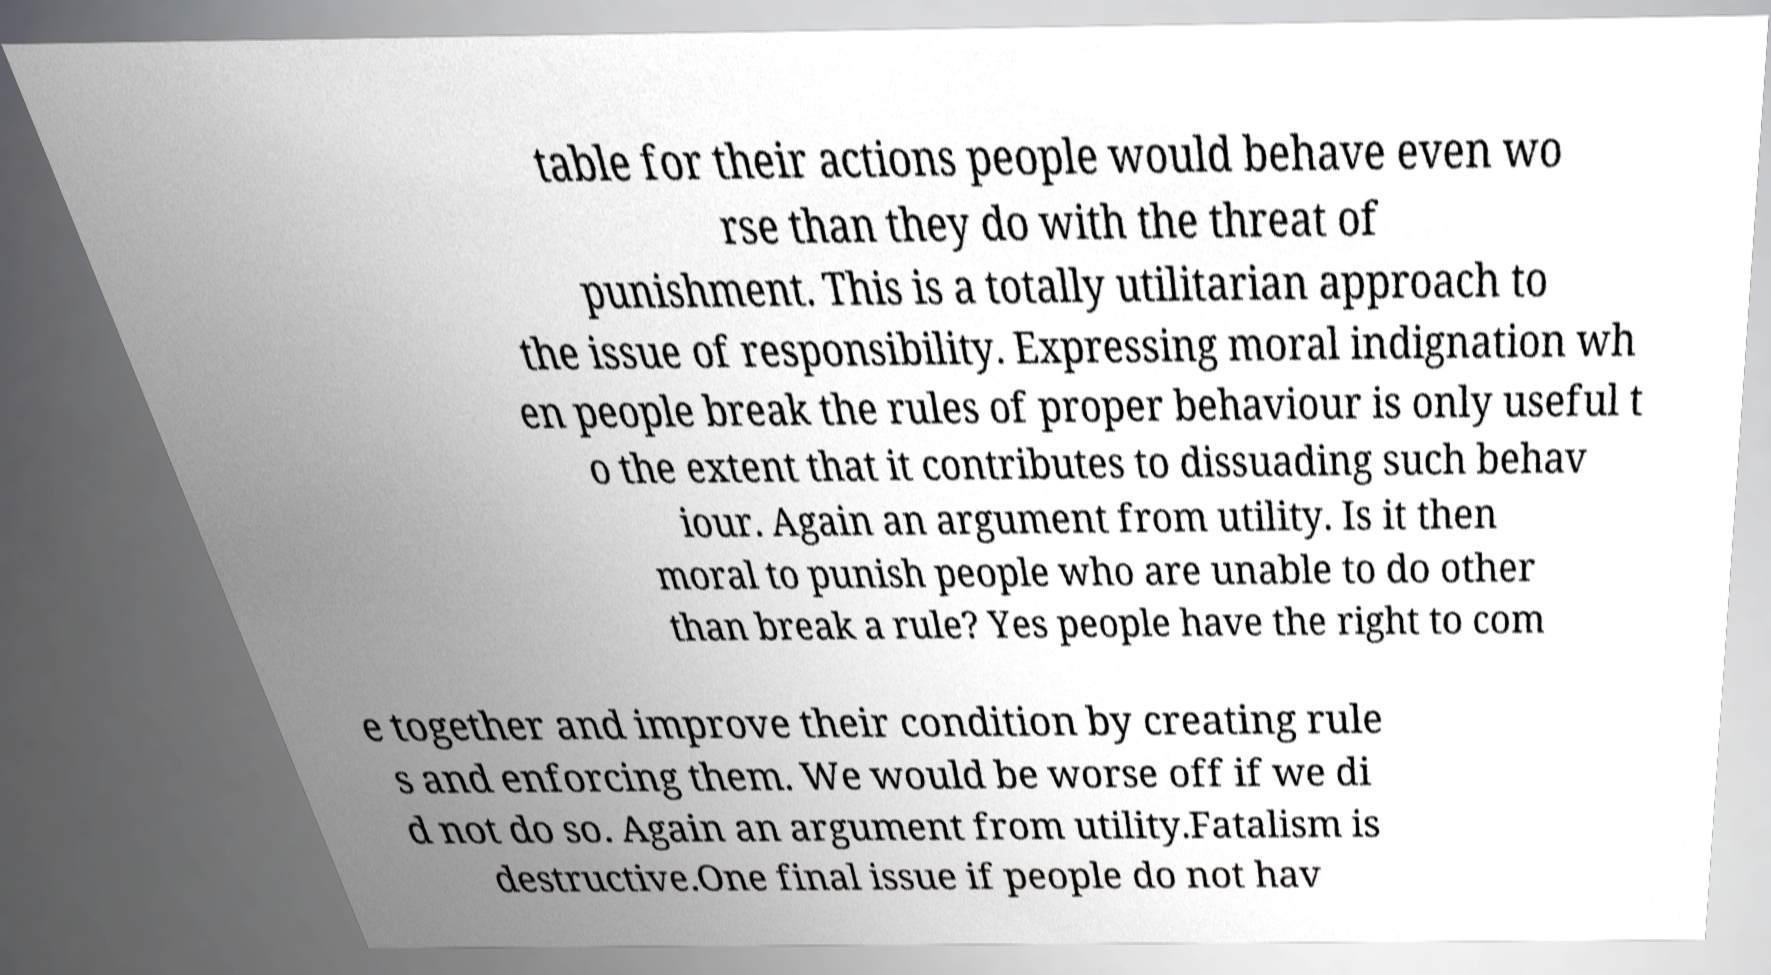Can you accurately transcribe the text from the provided image for me? table for their actions people would behave even wo rse than they do with the threat of punishment. This is a totally utilitarian approach to the issue of responsibility. Expressing moral indignation wh en people break the rules of proper behaviour is only useful t o the extent that it contributes to dissuading such behav iour. Again an argument from utility. Is it then moral to punish people who are unable to do other than break a rule? Yes people have the right to com e together and improve their condition by creating rule s and enforcing them. We would be worse off if we di d not do so. Again an argument from utility.Fatalism is destructive.One final issue if people do not hav 